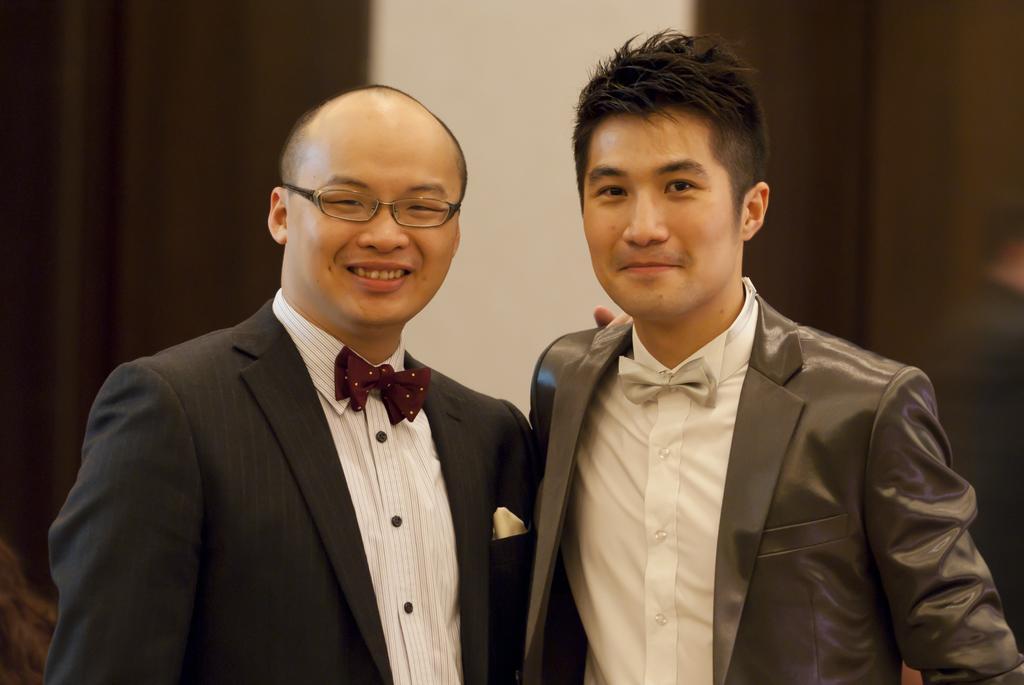Describe this image in one or two sentences. In this image I can see two people with white, black and grey color dresses. In the background I can see the curtains and the wall. 